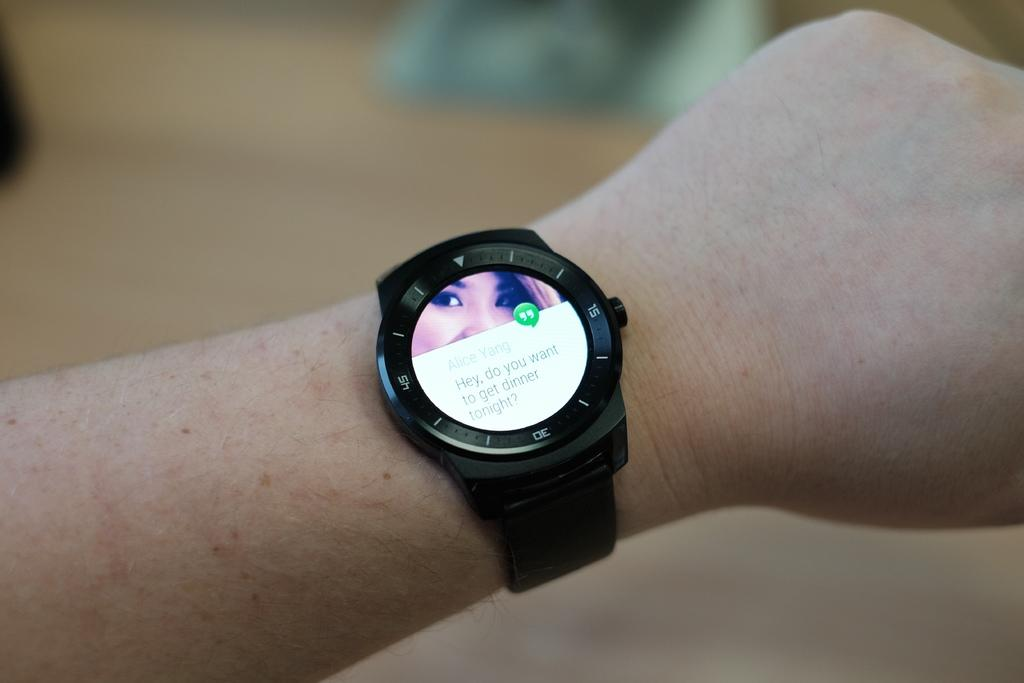What part of the human body is visible in the image? There is a human hand in the image. What is the hand wearing? The hand is wearing a black watch. What can be seen on the watch? A woman's face is visible on the watch. Is the hand holding any liquid in the image? There is no liquid visible in the image. Can you see any seashore or bath in the image? There is no seashore or bath present in the image. 